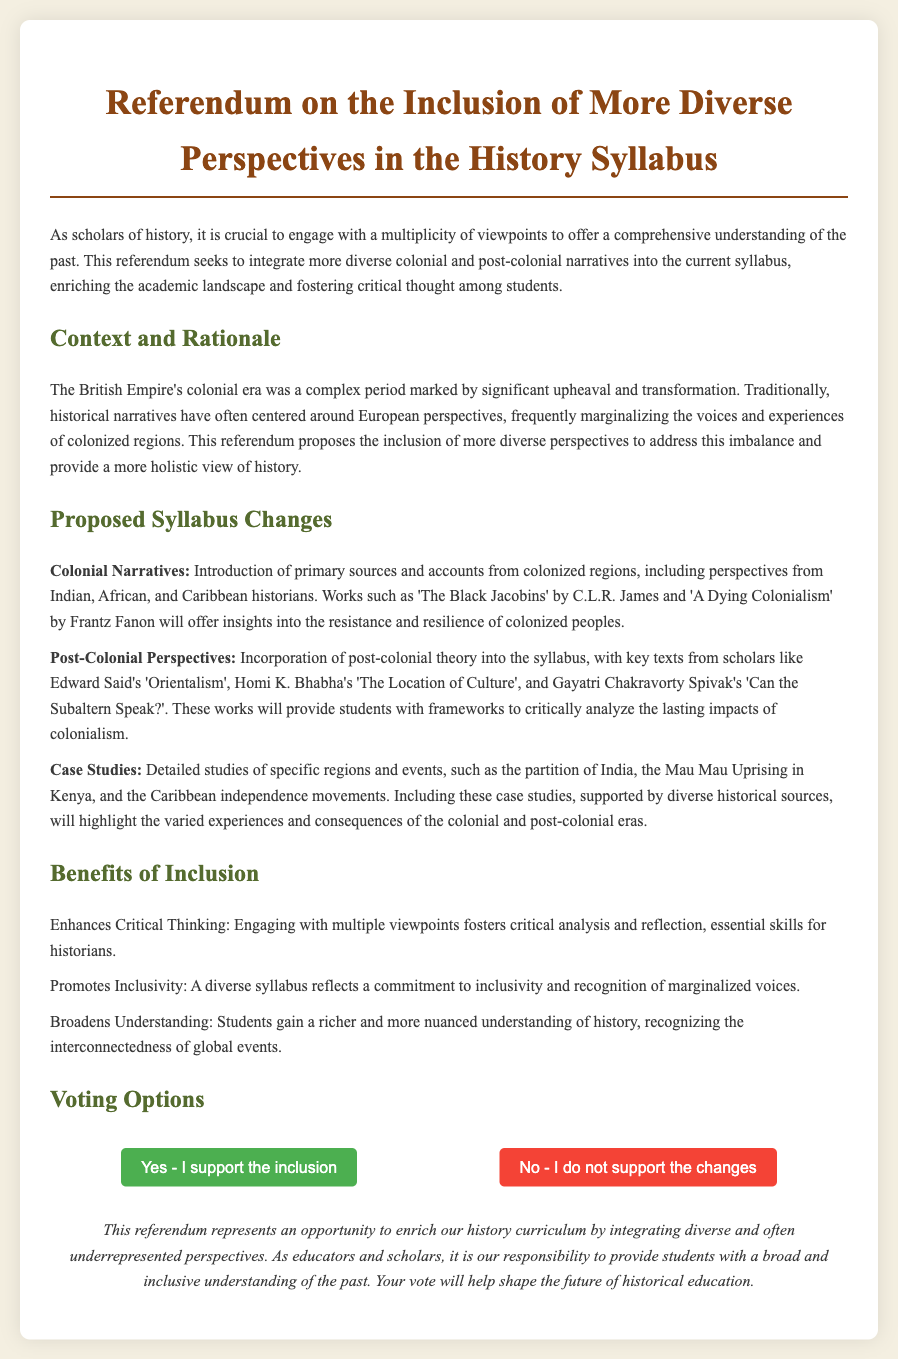What is the title of the referendum? The title of the referendum is stated at the top of the document.
Answer: Referendum on the Inclusion of More Diverse Perspectives in the History Syllabus Who are some authors mentioned for colonial narratives? The document lists specific authors whose works will be included for colonial narratives.
Answer: C.L.R. James and Frantz Fanon What key text is associated with post-colonial theory? A key text in post-colonial theory is mentioned in the proposed syllabus changes section.
Answer: Orientalism What case study event is mentioned in the proposed syllabus? The document provides examples of specific events as case studies for inclusion.
Answer: The partition of India What benefit is highlighted regarding critical thinking? The document states a specific benefit concerning students' skills in history.
Answer: Enhances Critical Thinking How many voting options are provided? The document includes a section detailing the options available for voting.
Answer: Two What color represents the "Yes" vote button? The document specifies the color coding for the voting buttons.
Answer: Green What is stated as a responsibility of educators in the conclusion? The conclusion mentions a specific duty of educators regarding curriculum.
Answer: Provide students with a broad and inclusive understanding of the past 